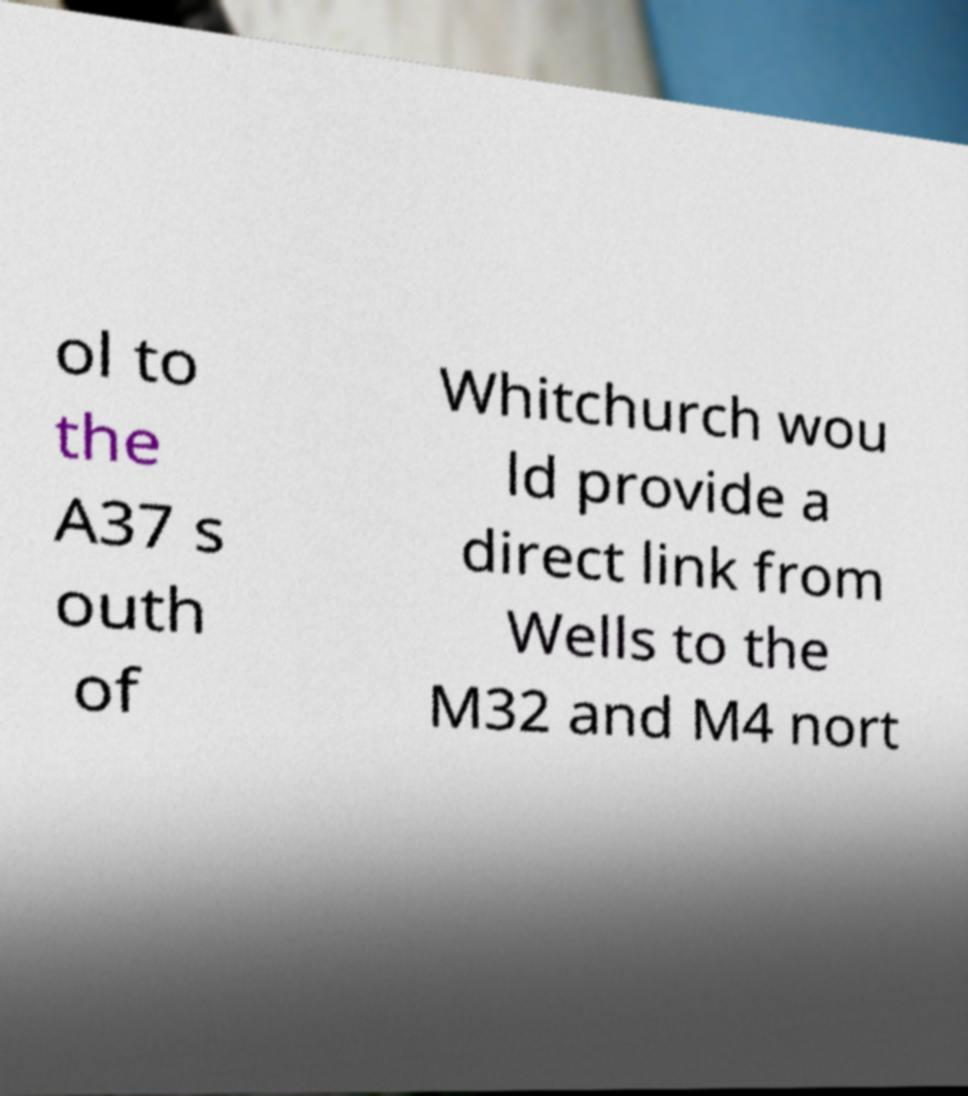There's text embedded in this image that I need extracted. Can you transcribe it verbatim? ol to the A37 s outh of Whitchurch wou ld provide a direct link from Wells to the M32 and M4 nort 